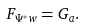<formula> <loc_0><loc_0><loc_500><loc_500>F _ { \Psi ^ { * } w } = G _ { a } .</formula> 